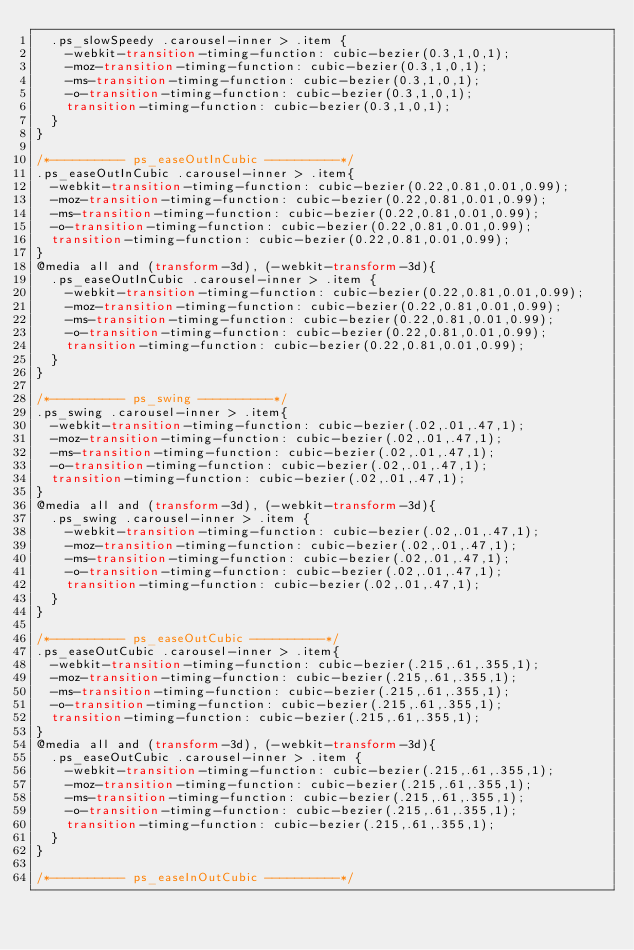<code> <loc_0><loc_0><loc_500><loc_500><_CSS_>  .ps_slowSpeedy .carousel-inner > .item {
    -webkit-transition-timing-function: cubic-bezier(0.3,1,0,1);
    -moz-transition-timing-function: cubic-bezier(0.3,1,0,1);
    -ms-transition-timing-function: cubic-bezier(0.3,1,0,1);
    -o-transition-timing-function: cubic-bezier(0.3,1,0,1);
    transition-timing-function: cubic-bezier(0.3,1,0,1);
  }
}

/*---------- ps_easeOutInCubic ----------*/
.ps_easeOutInCubic .carousel-inner > .item{
  -webkit-transition-timing-function: cubic-bezier(0.22,0.81,0.01,0.99);
  -moz-transition-timing-function: cubic-bezier(0.22,0.81,0.01,0.99);
  -ms-transition-timing-function: cubic-bezier(0.22,0.81,0.01,0.99);
  -o-transition-timing-function: cubic-bezier(0.22,0.81,0.01,0.99);
  transition-timing-function: cubic-bezier(0.22,0.81,0.01,0.99);
}
@media all and (transform-3d), (-webkit-transform-3d){
  .ps_easeOutInCubic .carousel-inner > .item {
    -webkit-transition-timing-function: cubic-bezier(0.22,0.81,0.01,0.99);
    -moz-transition-timing-function: cubic-bezier(0.22,0.81,0.01,0.99);
    -ms-transition-timing-function: cubic-bezier(0.22,0.81,0.01,0.99);
    -o-transition-timing-function: cubic-bezier(0.22,0.81,0.01,0.99);
    transition-timing-function: cubic-bezier(0.22,0.81,0.01,0.99);
  }
}

/*---------- ps_swing ----------*/
.ps_swing .carousel-inner > .item{
  -webkit-transition-timing-function: cubic-bezier(.02,.01,.47,1);
  -moz-transition-timing-function: cubic-bezier(.02,.01,.47,1);
  -ms-transition-timing-function: cubic-bezier(.02,.01,.47,1);
  -o-transition-timing-function: cubic-bezier(.02,.01,.47,1);
  transition-timing-function: cubic-bezier(.02,.01,.47,1);
}
@media all and (transform-3d), (-webkit-transform-3d){
  .ps_swing .carousel-inner > .item {
    -webkit-transition-timing-function: cubic-bezier(.02,.01,.47,1);
    -moz-transition-timing-function: cubic-bezier(.02,.01,.47,1);
    -ms-transition-timing-function: cubic-bezier(.02,.01,.47,1);
    -o-transition-timing-function: cubic-bezier(.02,.01,.47,1);
    transition-timing-function: cubic-bezier(.02,.01,.47,1);
  }
}

/*---------- ps_easeOutCubic ----------*/
.ps_easeOutCubic .carousel-inner > .item{
  -webkit-transition-timing-function: cubic-bezier(.215,.61,.355,1);
  -moz-transition-timing-function: cubic-bezier(.215,.61,.355,1);
  -ms-transition-timing-function: cubic-bezier(.215,.61,.355,1);
  -o-transition-timing-function: cubic-bezier(.215,.61,.355,1);
  transition-timing-function: cubic-bezier(.215,.61,.355,1);
}
@media all and (transform-3d), (-webkit-transform-3d){
  .ps_easeOutCubic .carousel-inner > .item {
    -webkit-transition-timing-function: cubic-bezier(.215,.61,.355,1);
    -moz-transition-timing-function: cubic-bezier(.215,.61,.355,1);
    -ms-transition-timing-function: cubic-bezier(.215,.61,.355,1);
    -o-transition-timing-function: cubic-bezier(.215,.61,.355,1);
    transition-timing-function: cubic-bezier(.215,.61,.355,1);
  }
}

/*---------- ps_easeInOutCubic ----------*/</code> 